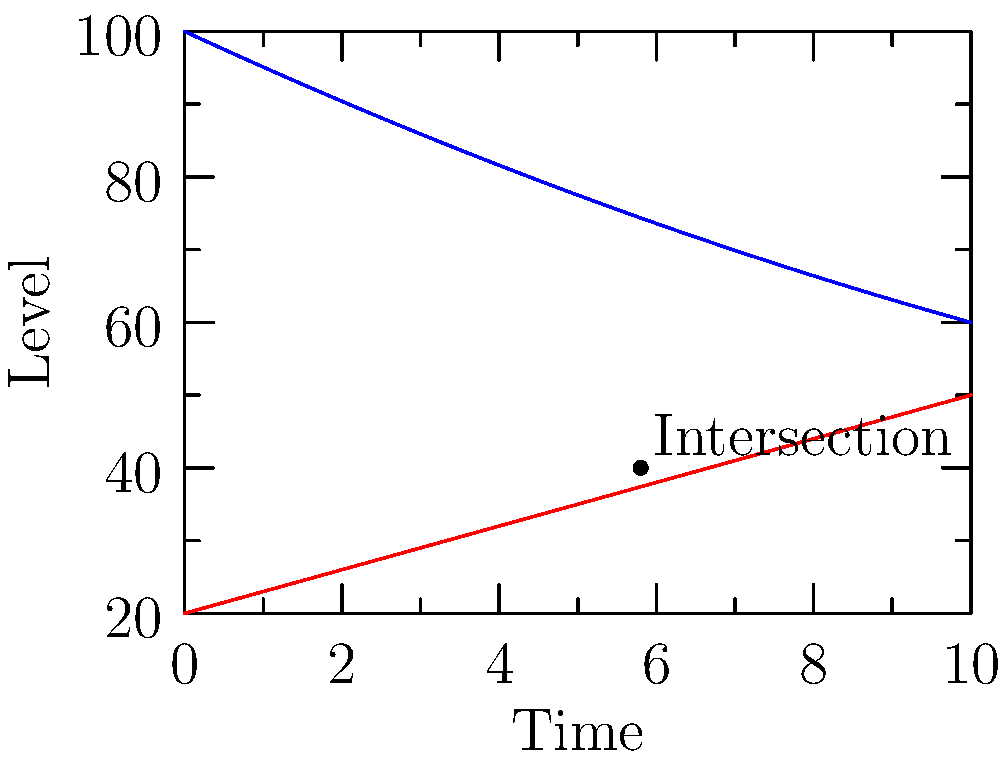In the line graph showing the relationship between resource depletion and economic growth over time, what does the intersection point of the two curves represent, and what implications might this have for sustainable development policies? To analyze this graph and its implications for sustainable development policies, let's follow these steps:

1. Identify the curves:
   - Blue curve: Resource Depletion
   - Red curve: Economic Growth

2. Observe the general trends:
   - Resource Depletion: Initially high, decreases, then increases again (quadratic shape)
   - Economic Growth: Steadily increasing (linear shape)

3. Locate the intersection point:
   - The curves intersect at approximately t = 5.8 on the time axis
   - The corresponding level is about 40 on the vertical axis

4. Interpret the intersection point:
   - This point represents where the rate of resource depletion equals the rate of economic growth
   - Before this point, economic growth is lower than resource depletion
   - After this point, economic growth surpasses resource depletion

5. Implications for sustainable development policies:
   - The intersection suggests a critical point where economic growth begins to outpace resource depletion
   - Policymakers should focus on maintaining economic growth while minimizing resource depletion
   - Strategies could include:
     a) Investing in renewable resources and circular economy practices
     b) Promoting resource efficiency and conservation
     c) Developing technologies that allow for economic growth with less resource intensity
   - The goal would be to flatten or reverse the resource depletion curve while maintaining economic growth

6. Long-term considerations:
   - The upward trend of the resource depletion curve after the intersection is concerning
   - Policies should aim to decouple economic growth from resource consumption to prevent future unsustainable patterns

By understanding this relationship, policymakers can develop targeted interventions to promote sustainable economic growth while preserving natural resources for future generations.
Answer: The intersection represents the point where economic growth rate equals resource depletion rate, indicating a need for policies that promote sustainable growth and resource conservation. 